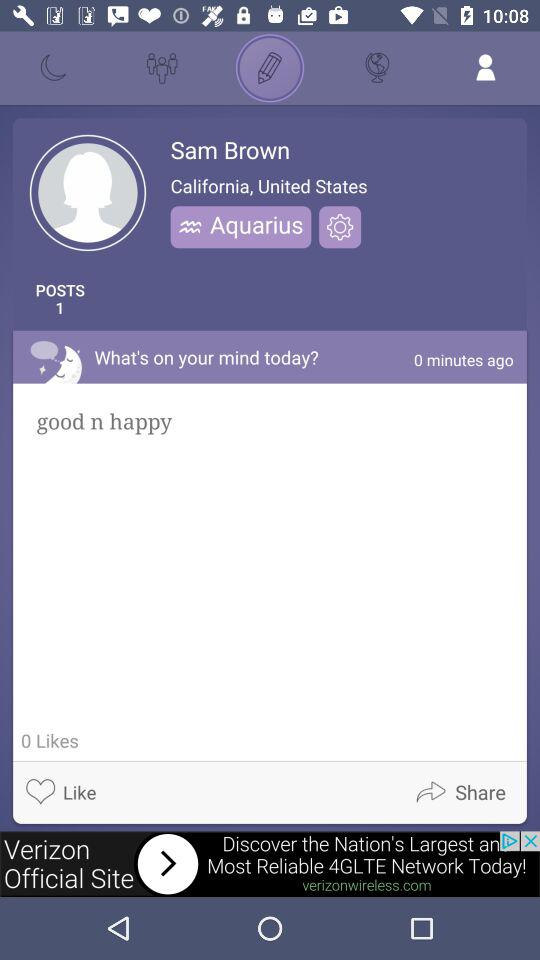How many posts are there? There is 1 post. 